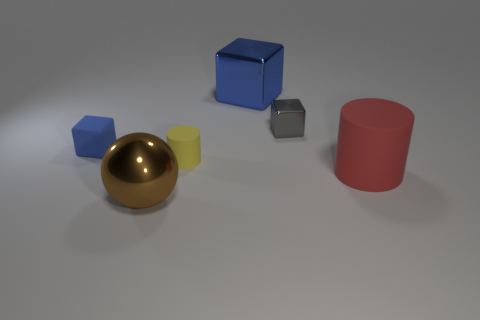What materials do the objects seem to be made of? Based on their appearance, the gold sphere seems to have a polished metallic finish, the small cube to the right of the sphere looks metallic as well, the blue cube appears matte, and the red cylinder seems to have a somewhat matte or diffuse surface, much like the yellow cube next to the gold sphere. 